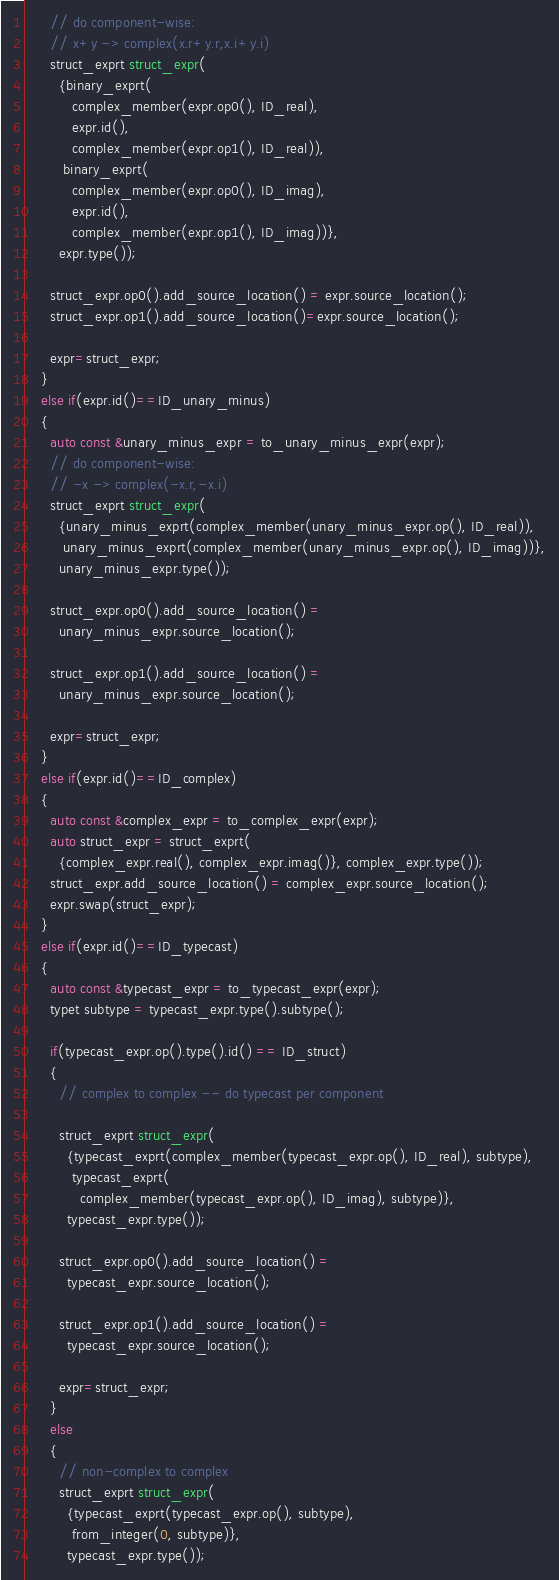Convert code to text. <code><loc_0><loc_0><loc_500><loc_500><_C++_>      // do component-wise:
      // x+y -> complex(x.r+y.r,x.i+y.i)
      struct_exprt struct_expr(
        {binary_exprt(
           complex_member(expr.op0(), ID_real),
           expr.id(),
           complex_member(expr.op1(), ID_real)),
         binary_exprt(
           complex_member(expr.op0(), ID_imag),
           expr.id(),
           complex_member(expr.op1(), ID_imag))},
        expr.type());

      struct_expr.op0().add_source_location() = expr.source_location();
      struct_expr.op1().add_source_location()=expr.source_location();

      expr=struct_expr;
    }
    else if(expr.id()==ID_unary_minus)
    {
      auto const &unary_minus_expr = to_unary_minus_expr(expr);
      // do component-wise:
      // -x -> complex(-x.r,-x.i)
      struct_exprt struct_expr(
        {unary_minus_exprt(complex_member(unary_minus_expr.op(), ID_real)),
         unary_minus_exprt(complex_member(unary_minus_expr.op(), ID_imag))},
        unary_minus_expr.type());

      struct_expr.op0().add_source_location() =
        unary_minus_expr.source_location();

      struct_expr.op1().add_source_location() =
        unary_minus_expr.source_location();

      expr=struct_expr;
    }
    else if(expr.id()==ID_complex)
    {
      auto const &complex_expr = to_complex_expr(expr);
      auto struct_expr = struct_exprt(
        {complex_expr.real(), complex_expr.imag()}, complex_expr.type());
      struct_expr.add_source_location() = complex_expr.source_location();
      expr.swap(struct_expr);
    }
    else if(expr.id()==ID_typecast)
    {
      auto const &typecast_expr = to_typecast_expr(expr);
      typet subtype = typecast_expr.type().subtype();

      if(typecast_expr.op().type().id() == ID_struct)
      {
        // complex to complex -- do typecast per component

        struct_exprt struct_expr(
          {typecast_exprt(complex_member(typecast_expr.op(), ID_real), subtype),
           typecast_exprt(
             complex_member(typecast_expr.op(), ID_imag), subtype)},
          typecast_expr.type());

        struct_expr.op0().add_source_location() =
          typecast_expr.source_location();

        struct_expr.op1().add_source_location() =
          typecast_expr.source_location();

        expr=struct_expr;
      }
      else
      {
        // non-complex to complex
        struct_exprt struct_expr(
          {typecast_exprt(typecast_expr.op(), subtype),
           from_integer(0, subtype)},
          typecast_expr.type());</code> 